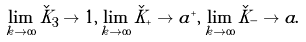Convert formula to latex. <formula><loc_0><loc_0><loc_500><loc_500>\lim _ { k \to \infty } \check { K } _ { 3 } \to 1 , \lim _ { k \to \infty } \check { K } _ { + } \to a ^ { + } , \lim _ { k \to \infty } \check { K } _ { - } \to a .</formula> 